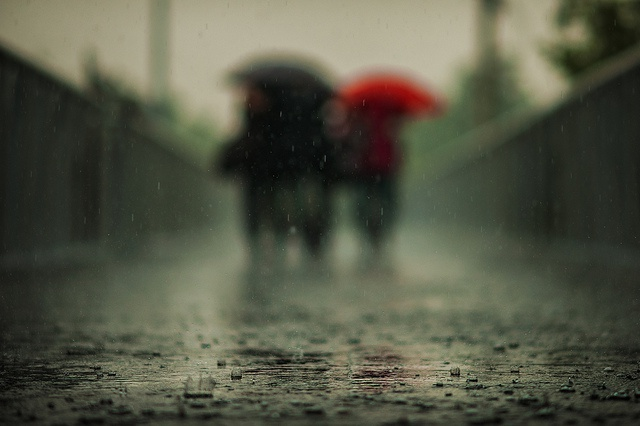Describe the objects in this image and their specific colors. I can see people in gray, black, maroon, and brown tones, people in gray, black, and maroon tones, people in gray, black, and darkgreen tones, umbrella in gray, maroon, tan, and brown tones, and umbrella in gray and black tones in this image. 